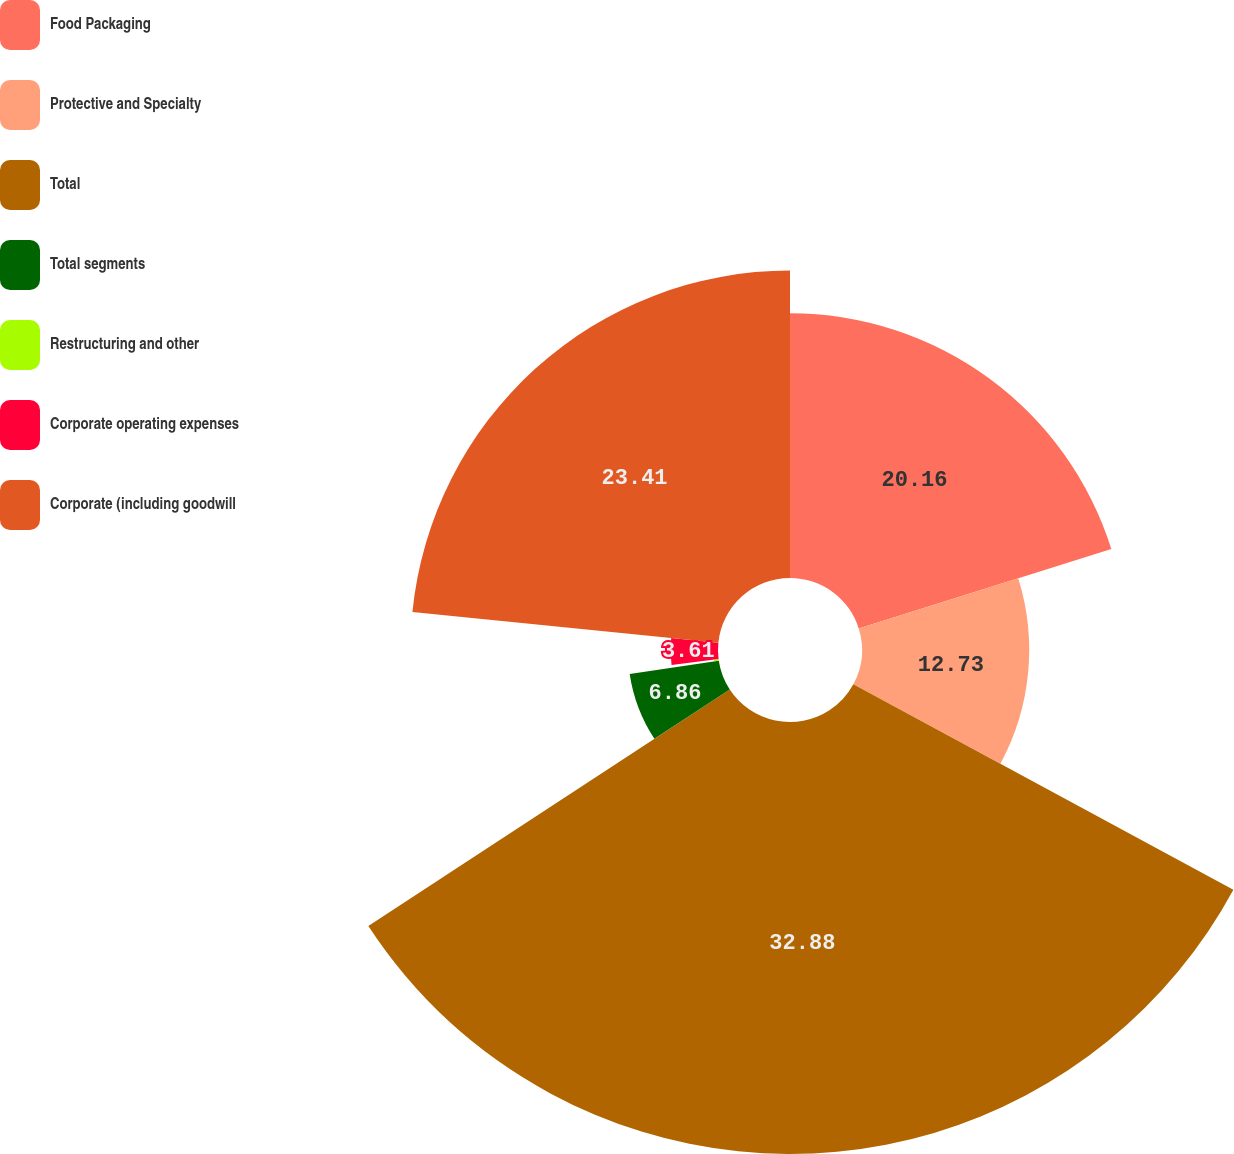Convert chart to OTSL. <chart><loc_0><loc_0><loc_500><loc_500><pie_chart><fcel>Food Packaging<fcel>Protective and Specialty<fcel>Total<fcel>Total segments<fcel>Restructuring and other<fcel>Corporate operating expenses<fcel>Corporate (including goodwill<nl><fcel>20.16%<fcel>12.73%<fcel>32.89%<fcel>6.86%<fcel>0.35%<fcel>3.61%<fcel>23.41%<nl></chart> 